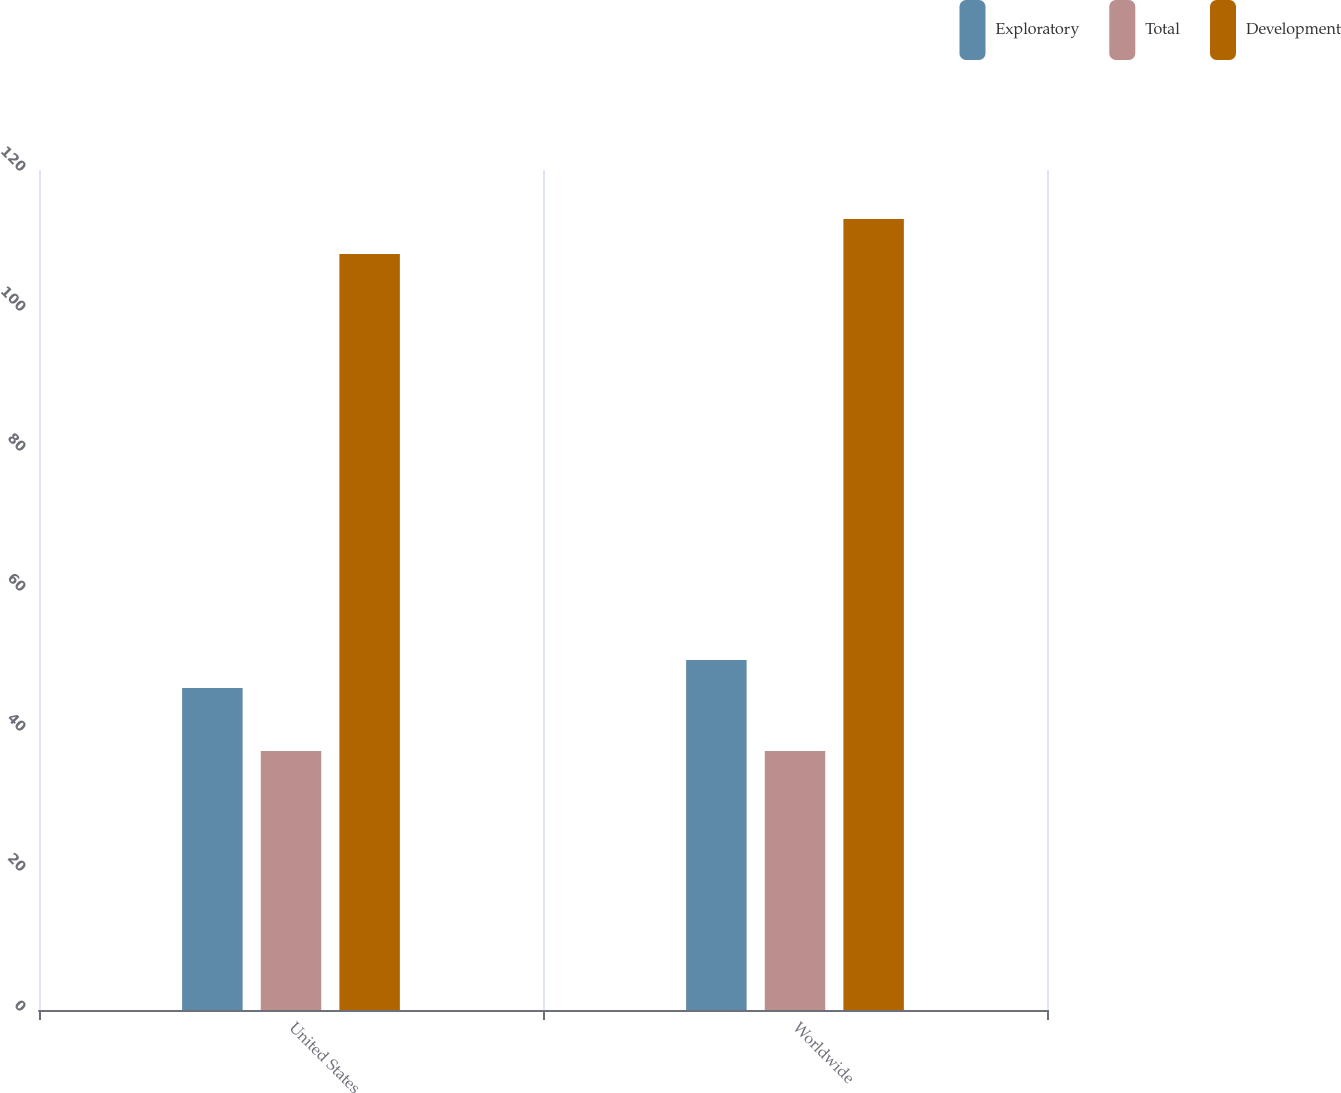<chart> <loc_0><loc_0><loc_500><loc_500><stacked_bar_chart><ecel><fcel>United States<fcel>Worldwide<nl><fcel>Exploratory<fcel>46<fcel>50<nl><fcel>Total<fcel>37<fcel>37<nl><fcel>Development<fcel>108<fcel>113<nl></chart> 